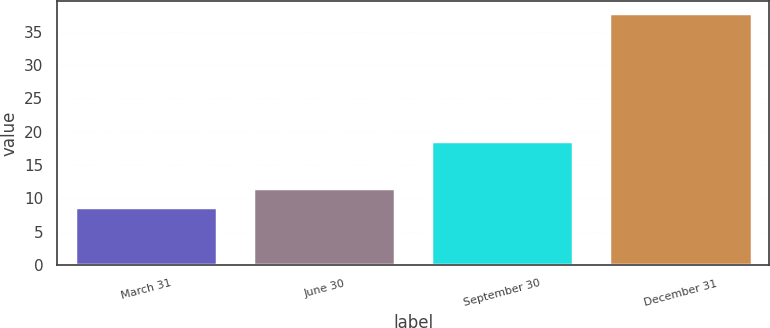<chart> <loc_0><loc_0><loc_500><loc_500><bar_chart><fcel>March 31<fcel>June 30<fcel>September 30<fcel>December 31<nl><fcel>8.69<fcel>11.59<fcel>18.66<fcel>37.72<nl></chart> 